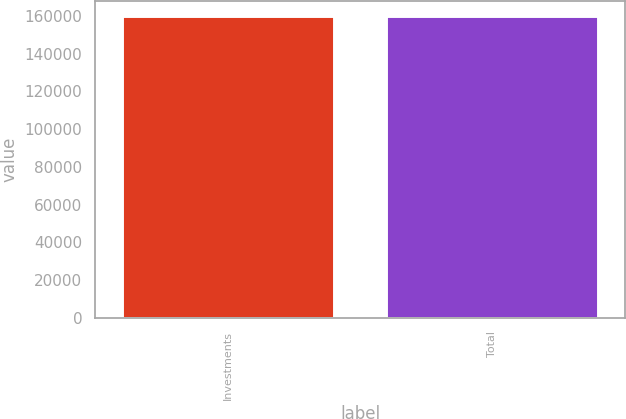<chart> <loc_0><loc_0><loc_500><loc_500><bar_chart><fcel>Investments<fcel>Total<nl><fcel>160185<fcel>160185<nl></chart> 